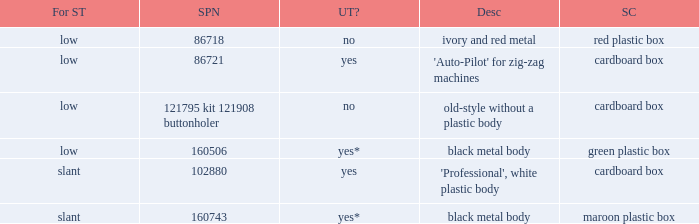What are all the different descriptions for the buttonholer with cardboard box for storage and a low shank type? 'Auto-Pilot' for zig-zag machines, old-style without a plastic body. 